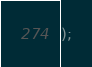Convert code to text. <code><loc_0><loc_0><loc_500><loc_500><_SQL_>);
</code> 